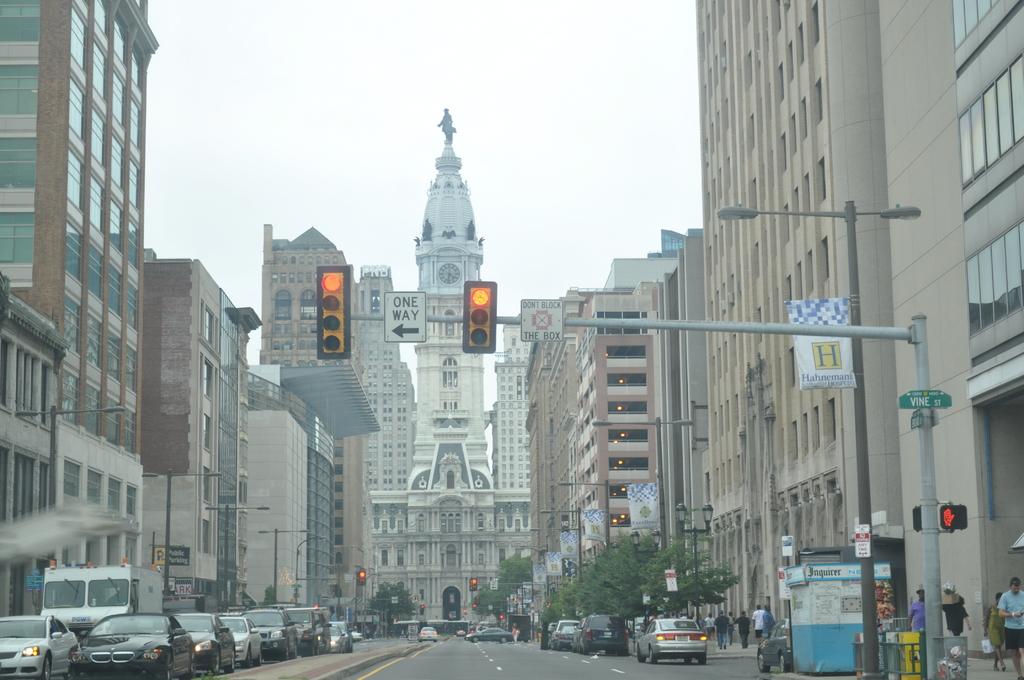Is this the one way street?
Provide a succinct answer. Yes. Is this vine street?
Provide a short and direct response. Yes. 